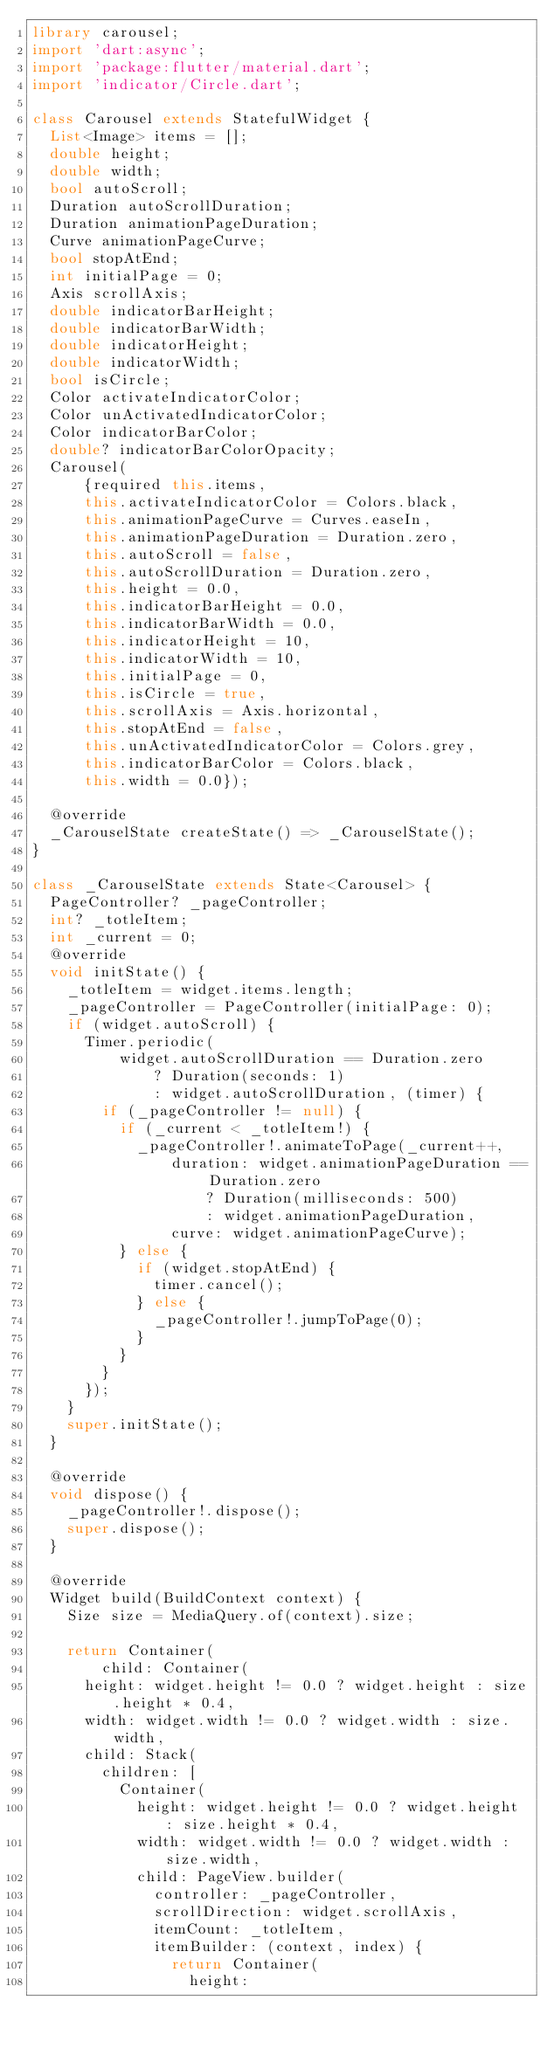Convert code to text. <code><loc_0><loc_0><loc_500><loc_500><_Dart_>library carousel;
import 'dart:async';
import 'package:flutter/material.dart';
import 'indicator/Circle.dart';

class Carousel extends StatefulWidget {
  List<Image> items = [];
  double height;
  double width;
  bool autoScroll;
  Duration autoScrollDuration;
  Duration animationPageDuration;
  Curve animationPageCurve;
  bool stopAtEnd;
  int initialPage = 0;
  Axis scrollAxis;
  double indicatorBarHeight;
  double indicatorBarWidth;
  double indicatorHeight;
  double indicatorWidth;
  bool isCircle;
  Color activateIndicatorColor;
  Color unActivatedIndicatorColor;
  Color indicatorBarColor;
  double? indicatorBarColorOpacity;
  Carousel(
      {required this.items,
      this.activateIndicatorColor = Colors.black,
      this.animationPageCurve = Curves.easeIn,
      this.animationPageDuration = Duration.zero,
      this.autoScroll = false,
      this.autoScrollDuration = Duration.zero,
      this.height = 0.0,
      this.indicatorBarHeight = 0.0,
      this.indicatorBarWidth = 0.0,
      this.indicatorHeight = 10,
      this.indicatorWidth = 10,
      this.initialPage = 0,
      this.isCircle = true,
      this.scrollAxis = Axis.horizontal,
      this.stopAtEnd = false,
      this.unActivatedIndicatorColor = Colors.grey,
      this.indicatorBarColor = Colors.black,
      this.width = 0.0});

  @override
  _CarouselState createState() => _CarouselState();
}

class _CarouselState extends State<Carousel> {
  PageController? _pageController;
  int? _totleItem;
  int _current = 0;
  @override
  void initState() {
    _totleItem = widget.items.length;
    _pageController = PageController(initialPage: 0);
    if (widget.autoScroll) {
      Timer.periodic(
          widget.autoScrollDuration == Duration.zero
              ? Duration(seconds: 1)
              : widget.autoScrollDuration, (timer) {
        if (_pageController != null) {
          if (_current < _totleItem!) {
            _pageController!.animateToPage(_current++,
                duration: widget.animationPageDuration == Duration.zero
                    ? Duration(milliseconds: 500)
                    : widget.animationPageDuration,
                curve: widget.animationPageCurve);
          } else {
            if (widget.stopAtEnd) {
              timer.cancel();
            } else {
              _pageController!.jumpToPage(0);
            }
          }
        }
      });
    }
    super.initState();
  }

  @override
  void dispose() {
    _pageController!.dispose();
    super.dispose();
  }

  @override
  Widget build(BuildContext context) {
    Size size = MediaQuery.of(context).size;

    return Container(
        child: Container(
      height: widget.height != 0.0 ? widget.height : size.height * 0.4,
      width: widget.width != 0.0 ? widget.width : size.width,
      child: Stack(
        children: [
          Container(
            height: widget.height != 0.0 ? widget.height : size.height * 0.4,
            width: widget.width != 0.0 ? widget.width : size.width,
            child: PageView.builder(
              controller: _pageController,
              scrollDirection: widget.scrollAxis,
              itemCount: _totleItem,
              itemBuilder: (context, index) {
                return Container(
                  height:</code> 